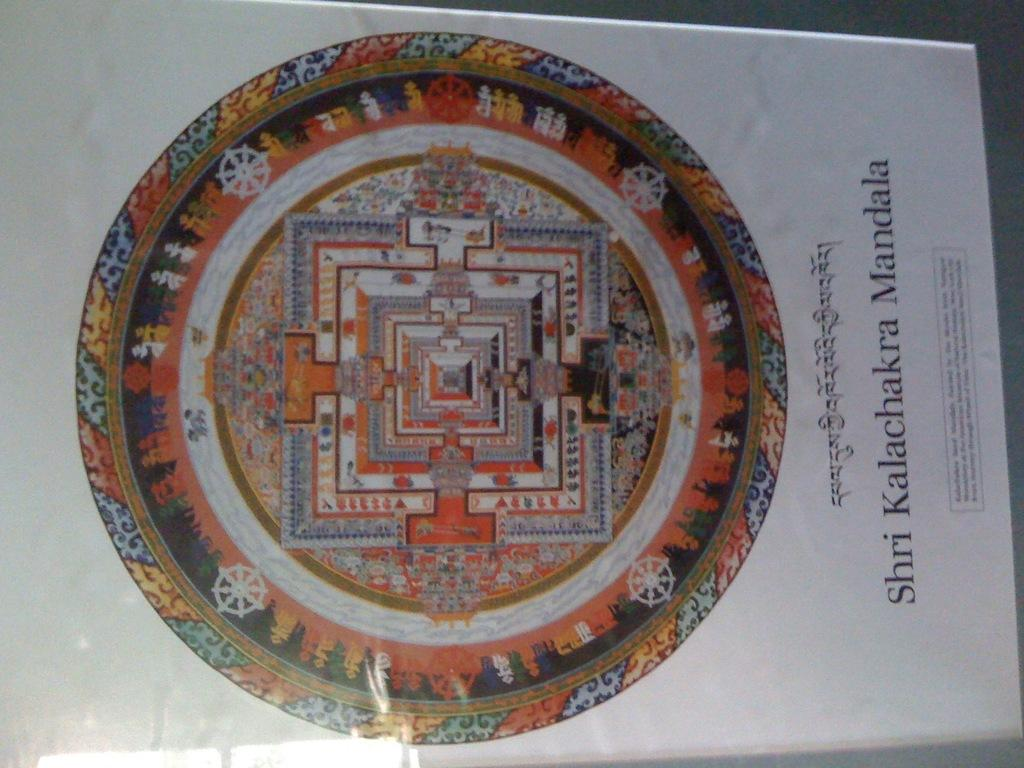<image>
Summarize the visual content of the image. the word shri is next top a large wheel that is colorful 